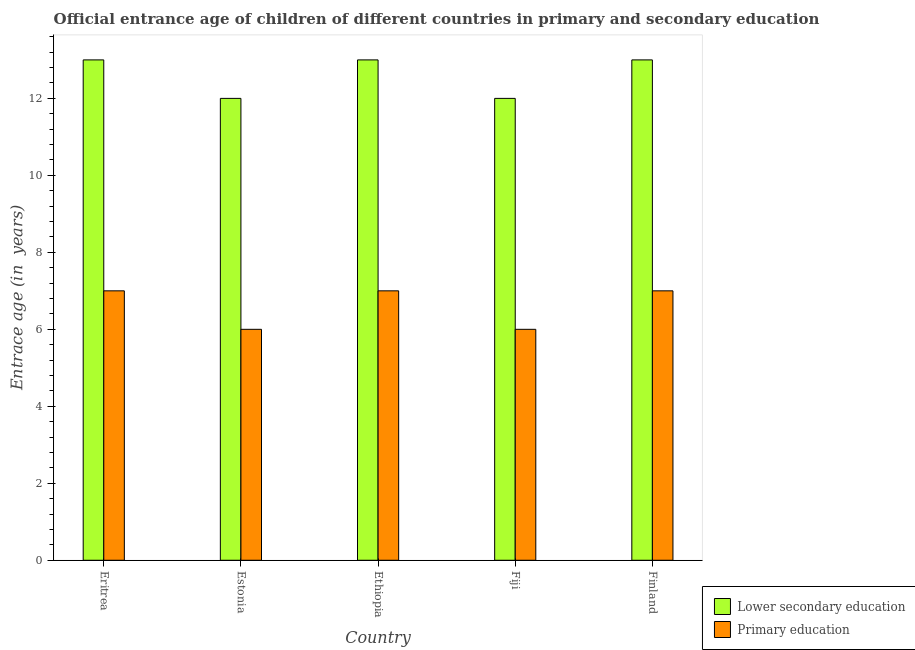Are the number of bars on each tick of the X-axis equal?
Ensure brevity in your answer.  Yes. How many bars are there on the 1st tick from the left?
Your answer should be compact. 2. How many bars are there on the 1st tick from the right?
Offer a terse response. 2. What is the label of the 2nd group of bars from the left?
Your response must be concise. Estonia. In how many cases, is the number of bars for a given country not equal to the number of legend labels?
Provide a short and direct response. 0. Across all countries, what is the maximum entrance age of chiildren in primary education?
Keep it short and to the point. 7. Across all countries, what is the minimum entrance age of children in lower secondary education?
Keep it short and to the point. 12. In which country was the entrance age of chiildren in primary education maximum?
Your answer should be very brief. Eritrea. In which country was the entrance age of children in lower secondary education minimum?
Give a very brief answer. Estonia. What is the total entrance age of chiildren in primary education in the graph?
Your answer should be compact. 33. What is the difference between the entrance age of children in lower secondary education in Estonia and that in Fiji?
Provide a succinct answer. 0. What is the difference between the entrance age of children in lower secondary education in Estonia and the entrance age of chiildren in primary education in Finland?
Your answer should be very brief. 5. In how many countries, is the entrance age of chiildren in primary education greater than 9.2 years?
Give a very brief answer. 0. What is the ratio of the entrance age of chiildren in primary education in Fiji to that in Finland?
Make the answer very short. 0.86. Is the difference between the entrance age of chiildren in primary education in Eritrea and Ethiopia greater than the difference between the entrance age of children in lower secondary education in Eritrea and Ethiopia?
Keep it short and to the point. No. What is the difference between the highest and the second highest entrance age of chiildren in primary education?
Give a very brief answer. 0. What is the difference between the highest and the lowest entrance age of chiildren in primary education?
Offer a terse response. 1. In how many countries, is the entrance age of chiildren in primary education greater than the average entrance age of chiildren in primary education taken over all countries?
Give a very brief answer. 3. What does the 1st bar from the left in Fiji represents?
Offer a very short reply. Lower secondary education. What does the 2nd bar from the right in Finland represents?
Make the answer very short. Lower secondary education. How many bars are there?
Your answer should be very brief. 10. How many countries are there in the graph?
Keep it short and to the point. 5. What is the difference between two consecutive major ticks on the Y-axis?
Provide a short and direct response. 2. Are the values on the major ticks of Y-axis written in scientific E-notation?
Your answer should be compact. No. Where does the legend appear in the graph?
Offer a very short reply. Bottom right. How many legend labels are there?
Offer a very short reply. 2. How are the legend labels stacked?
Provide a short and direct response. Vertical. What is the title of the graph?
Keep it short and to the point. Official entrance age of children of different countries in primary and secondary education. Does "Female" appear as one of the legend labels in the graph?
Offer a very short reply. No. What is the label or title of the Y-axis?
Ensure brevity in your answer.  Entrace age (in  years). What is the Entrace age (in  years) of Primary education in Eritrea?
Ensure brevity in your answer.  7. What is the Entrace age (in  years) of Primary education in Estonia?
Provide a succinct answer. 6. What is the Entrace age (in  years) in Primary education in Ethiopia?
Keep it short and to the point. 7. What is the Entrace age (in  years) in Primary education in Fiji?
Your response must be concise. 6. Across all countries, what is the maximum Entrace age (in  years) of Lower secondary education?
Offer a terse response. 13. Across all countries, what is the minimum Entrace age (in  years) in Primary education?
Give a very brief answer. 6. What is the total Entrace age (in  years) in Lower secondary education in the graph?
Provide a succinct answer. 63. What is the difference between the Entrace age (in  years) in Primary education in Eritrea and that in Estonia?
Your answer should be compact. 1. What is the difference between the Entrace age (in  years) of Lower secondary education in Eritrea and that in Ethiopia?
Provide a short and direct response. 0. What is the difference between the Entrace age (in  years) in Primary education in Eritrea and that in Ethiopia?
Your response must be concise. 0. What is the difference between the Entrace age (in  years) in Primary education in Eritrea and that in Finland?
Your answer should be very brief. 0. What is the difference between the Entrace age (in  years) of Lower secondary education in Estonia and that in Fiji?
Your answer should be very brief. 0. What is the difference between the Entrace age (in  years) of Primary education in Estonia and that in Fiji?
Give a very brief answer. 0. What is the difference between the Entrace age (in  years) in Primary education in Estonia and that in Finland?
Keep it short and to the point. -1. What is the difference between the Entrace age (in  years) of Primary education in Ethiopia and that in Fiji?
Ensure brevity in your answer.  1. What is the difference between the Entrace age (in  years) of Lower secondary education in Fiji and that in Finland?
Make the answer very short. -1. What is the difference between the Entrace age (in  years) in Lower secondary education in Eritrea and the Entrace age (in  years) in Primary education in Estonia?
Keep it short and to the point. 7. What is the difference between the Entrace age (in  years) of Lower secondary education in Estonia and the Entrace age (in  years) of Primary education in Ethiopia?
Your answer should be very brief. 5. What is the difference between the Entrace age (in  years) of Lower secondary education in Estonia and the Entrace age (in  years) of Primary education in Fiji?
Offer a very short reply. 6. What is the difference between the Entrace age (in  years) of Lower secondary education in Ethiopia and the Entrace age (in  years) of Primary education in Fiji?
Your response must be concise. 7. What is the difference between the Entrace age (in  years) in Lower secondary education in Ethiopia and the Entrace age (in  years) in Primary education in Finland?
Keep it short and to the point. 6. What is the difference between the Entrace age (in  years) of Lower secondary education and Entrace age (in  years) of Primary education in Eritrea?
Your answer should be compact. 6. What is the difference between the Entrace age (in  years) of Lower secondary education and Entrace age (in  years) of Primary education in Fiji?
Offer a very short reply. 6. What is the difference between the Entrace age (in  years) of Lower secondary education and Entrace age (in  years) of Primary education in Finland?
Give a very brief answer. 6. What is the ratio of the Entrace age (in  years) of Lower secondary education in Eritrea to that in Estonia?
Give a very brief answer. 1.08. What is the ratio of the Entrace age (in  years) in Lower secondary education in Eritrea to that in Ethiopia?
Make the answer very short. 1. What is the ratio of the Entrace age (in  years) in Primary education in Eritrea to that in Ethiopia?
Offer a terse response. 1. What is the ratio of the Entrace age (in  years) of Primary education in Eritrea to that in Finland?
Keep it short and to the point. 1. What is the ratio of the Entrace age (in  years) in Lower secondary education in Estonia to that in Fiji?
Your answer should be compact. 1. What is the ratio of the Entrace age (in  years) in Primary education in Estonia to that in Fiji?
Provide a succinct answer. 1. What is the ratio of the Entrace age (in  years) of Lower secondary education in Estonia to that in Finland?
Ensure brevity in your answer.  0.92. What is the ratio of the Entrace age (in  years) of Lower secondary education in Ethiopia to that in Finland?
Offer a terse response. 1. What is the ratio of the Entrace age (in  years) of Lower secondary education in Fiji to that in Finland?
Your answer should be compact. 0.92. What is the ratio of the Entrace age (in  years) in Primary education in Fiji to that in Finland?
Make the answer very short. 0.86. What is the difference between the highest and the second highest Entrace age (in  years) in Lower secondary education?
Make the answer very short. 0. What is the difference between the highest and the second highest Entrace age (in  years) in Primary education?
Keep it short and to the point. 0. What is the difference between the highest and the lowest Entrace age (in  years) in Primary education?
Provide a succinct answer. 1. 